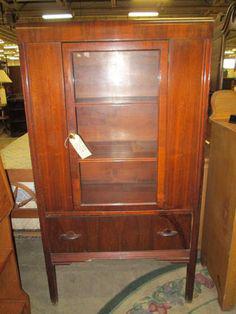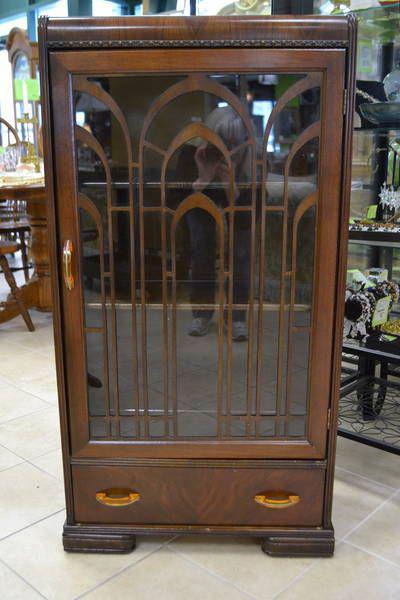The first image is the image on the left, the second image is the image on the right. Examine the images to the left and right. Is the description "One wooden cabinet on tall legs has a center rectangular glass panel on the front." accurate? Answer yes or no. Yes. The first image is the image on the left, the second image is the image on the right. Considering the images on both sides, is "Right image features a cabinet with slender feet instead of wedge feet." valid? Answer yes or no. No. 